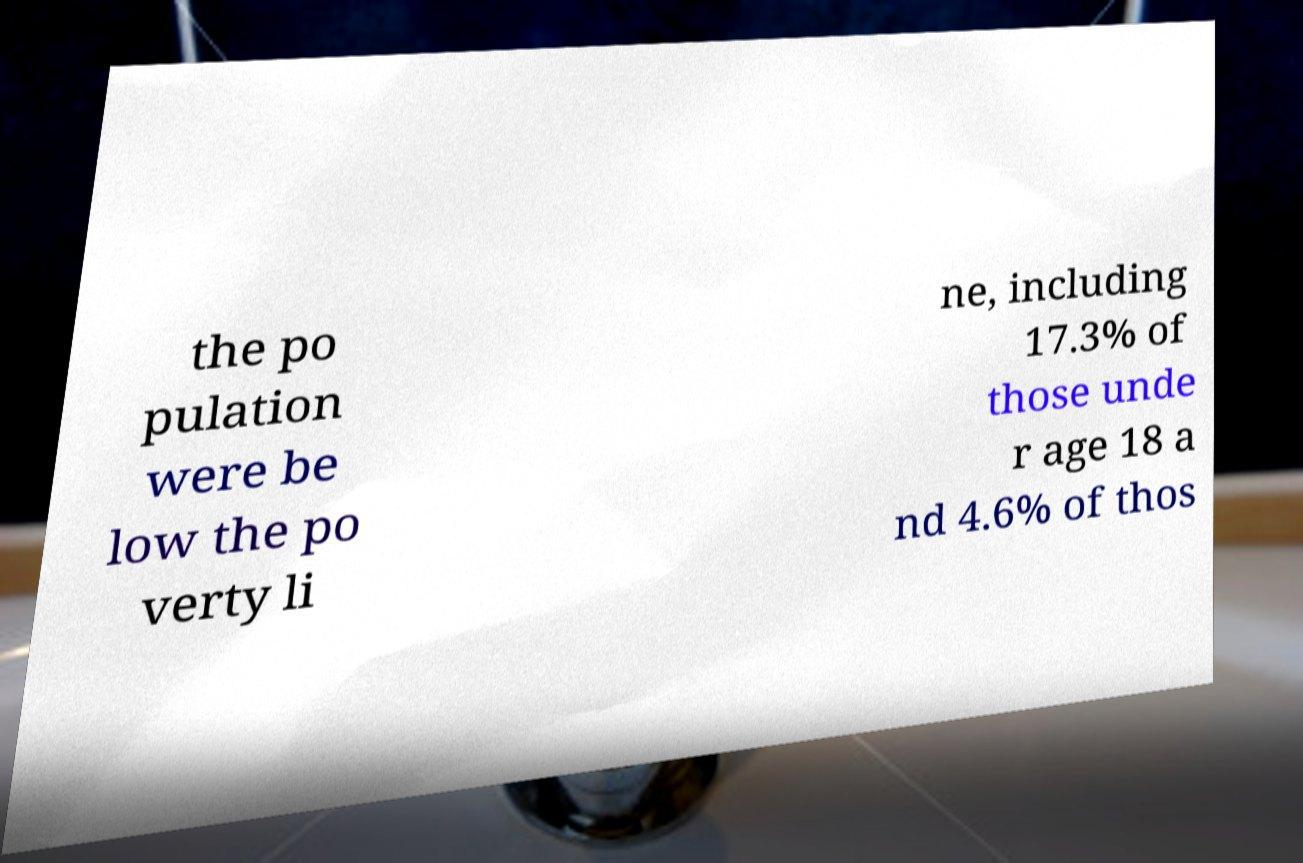Please read and relay the text visible in this image. What does it say? the po pulation were be low the po verty li ne, including 17.3% of those unde r age 18 a nd 4.6% of thos 